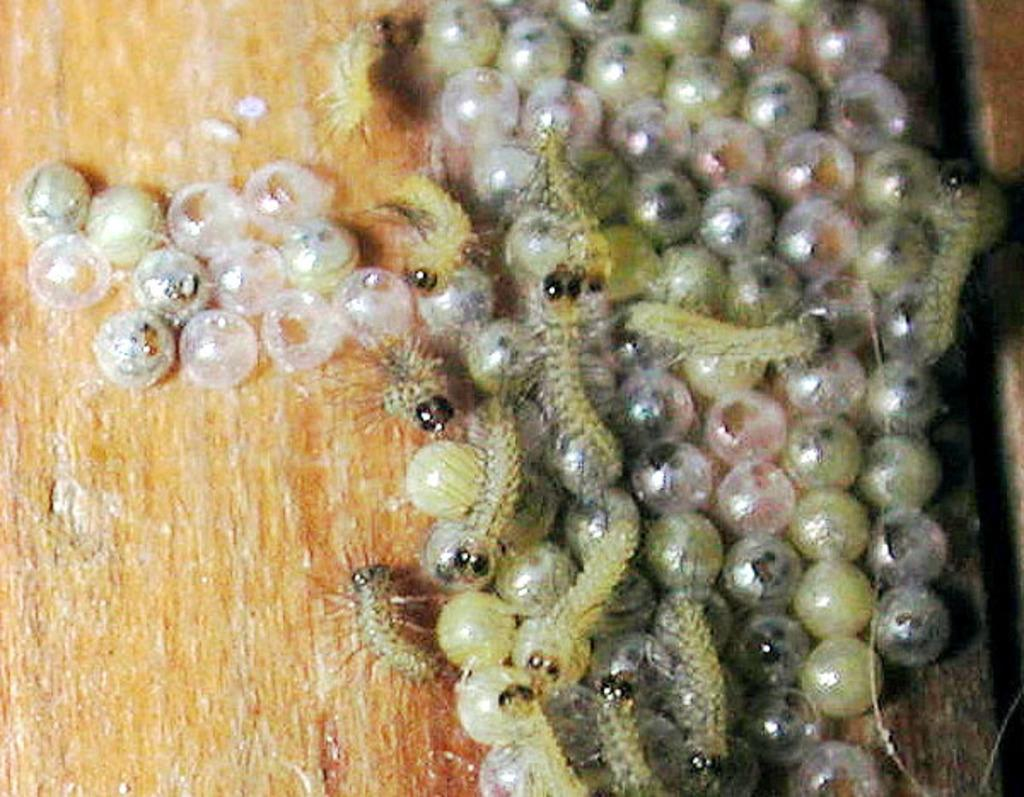What object made of wood can be seen in the image? There is a wooden stick in the image. What type of eggs are present in the image? There are insect eggs in the image. What living organisms can be seen in the image? There are insects in the image. What type of calculator can be seen in the image? There is no calculator present in the image. Can you tell me how many dogs are visible in the image? There are no dogs present in the image. 